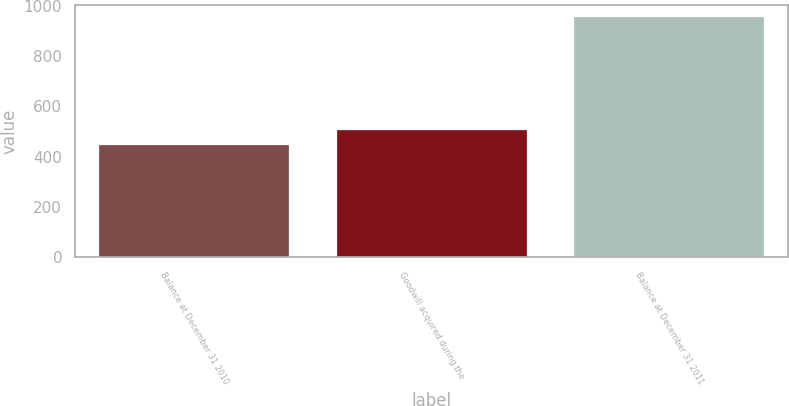Convert chart. <chart><loc_0><loc_0><loc_500><loc_500><bar_chart><fcel>Balance at December 31 2010<fcel>Goodwill acquired during the<fcel>Balance at December 31 2011<nl><fcel>446<fcel>507<fcel>953<nl></chart> 